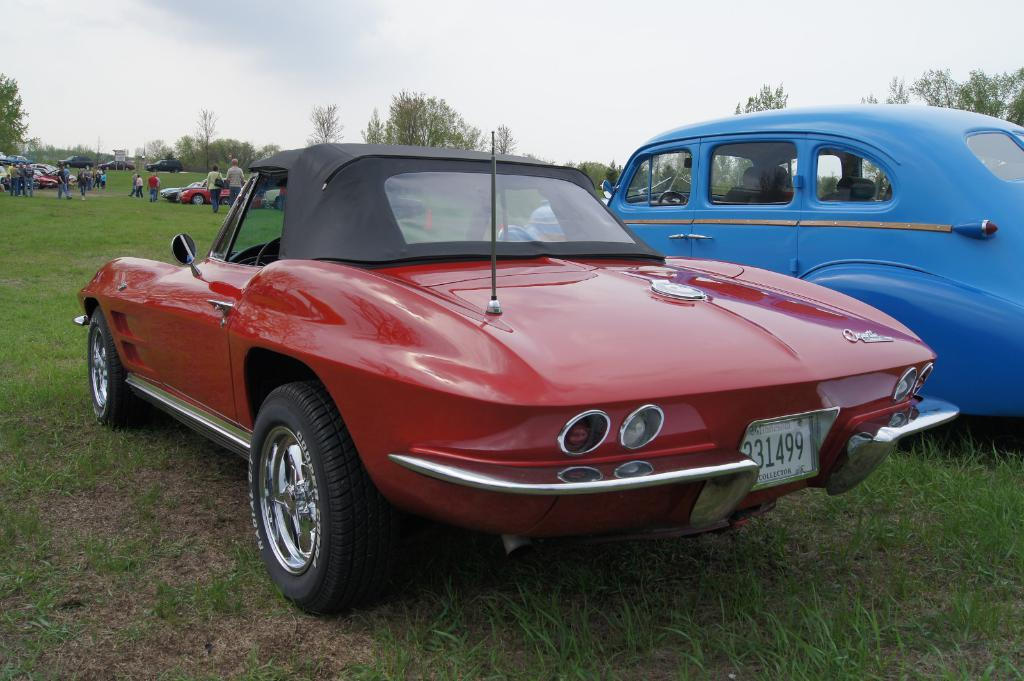What is the primary surface visible in the image? There is a ground in the image. What types of objects are on the ground? Vehicles are present on the ground. Are there any living beings visible in the image? Yes, there are persons visible in the image. What type of natural environment can be seen in the image? Trees are visible in the image. What is visible at the top of the image? The sky is visible at the top of the image. What type of wine is being served at the picnic in the image? There is no picnic or wine present in the image; it features a ground with vehicles, persons, trees, and the sky. How many ducks are visible in the image? There are no ducks present in the image. 